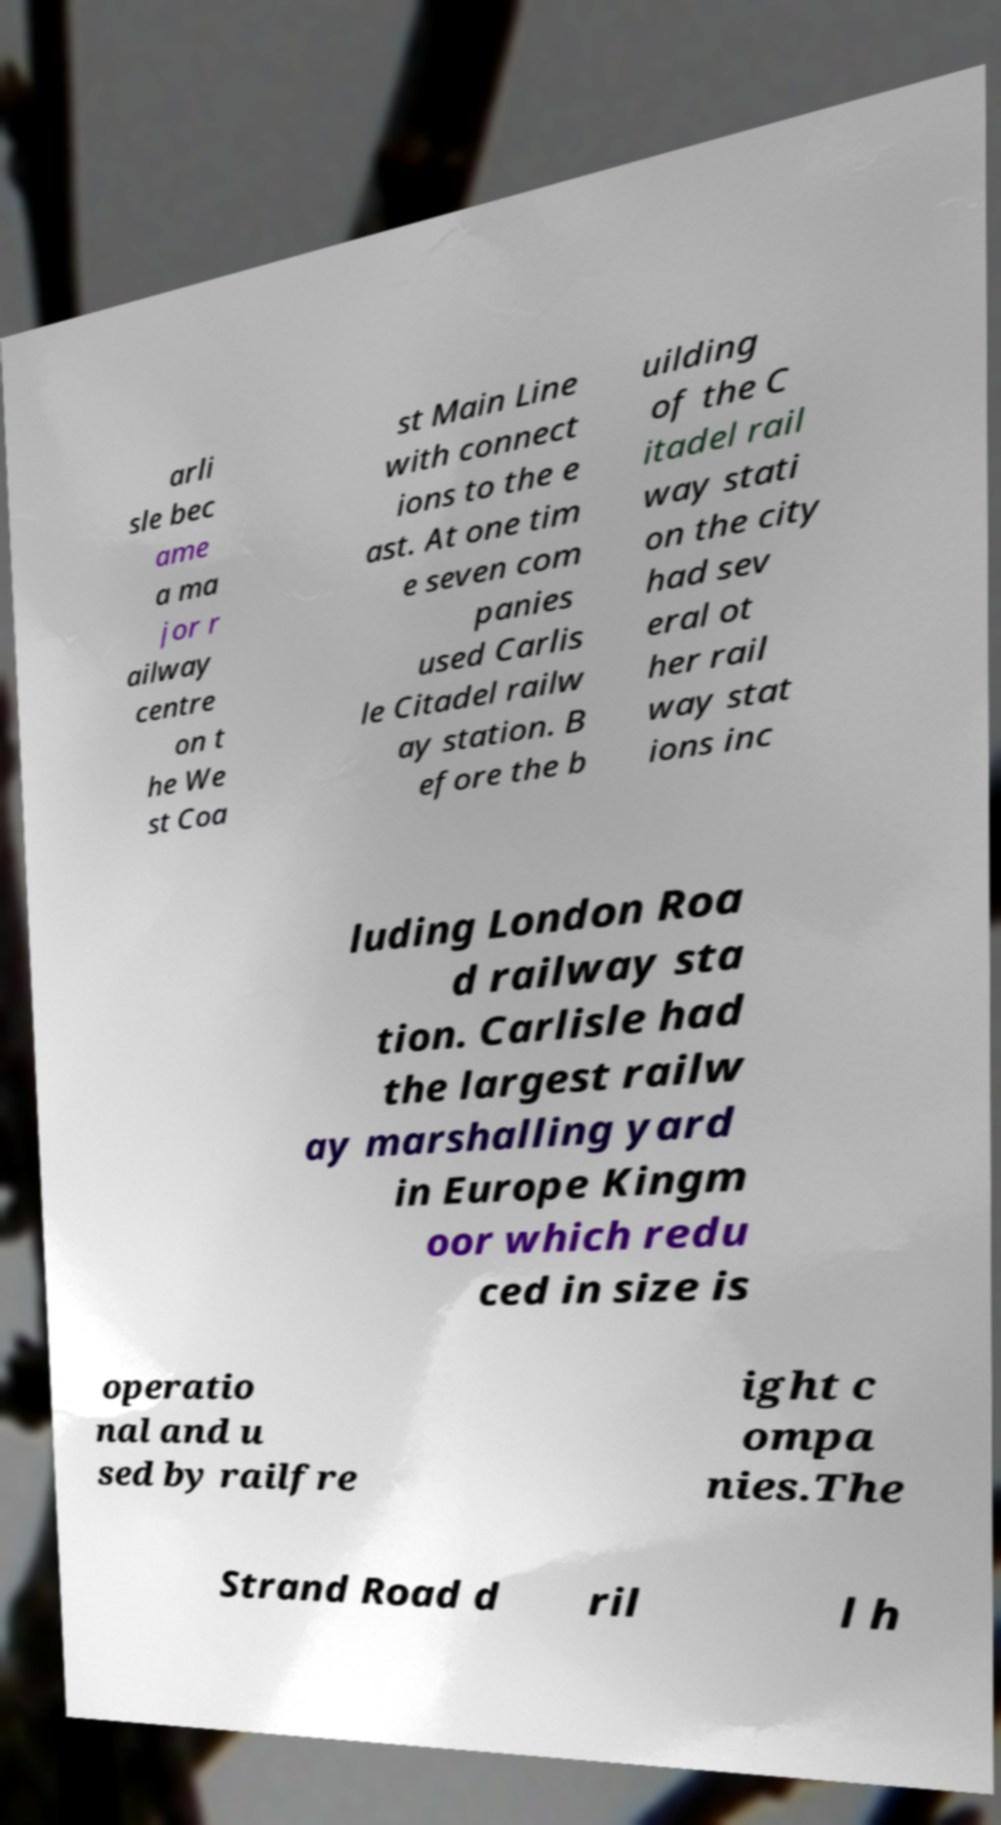Please read and relay the text visible in this image. What does it say? arli sle bec ame a ma jor r ailway centre on t he We st Coa st Main Line with connect ions to the e ast. At one tim e seven com panies used Carlis le Citadel railw ay station. B efore the b uilding of the C itadel rail way stati on the city had sev eral ot her rail way stat ions inc luding London Roa d railway sta tion. Carlisle had the largest railw ay marshalling yard in Europe Kingm oor which redu ced in size is operatio nal and u sed by railfre ight c ompa nies.The Strand Road d ril l h 